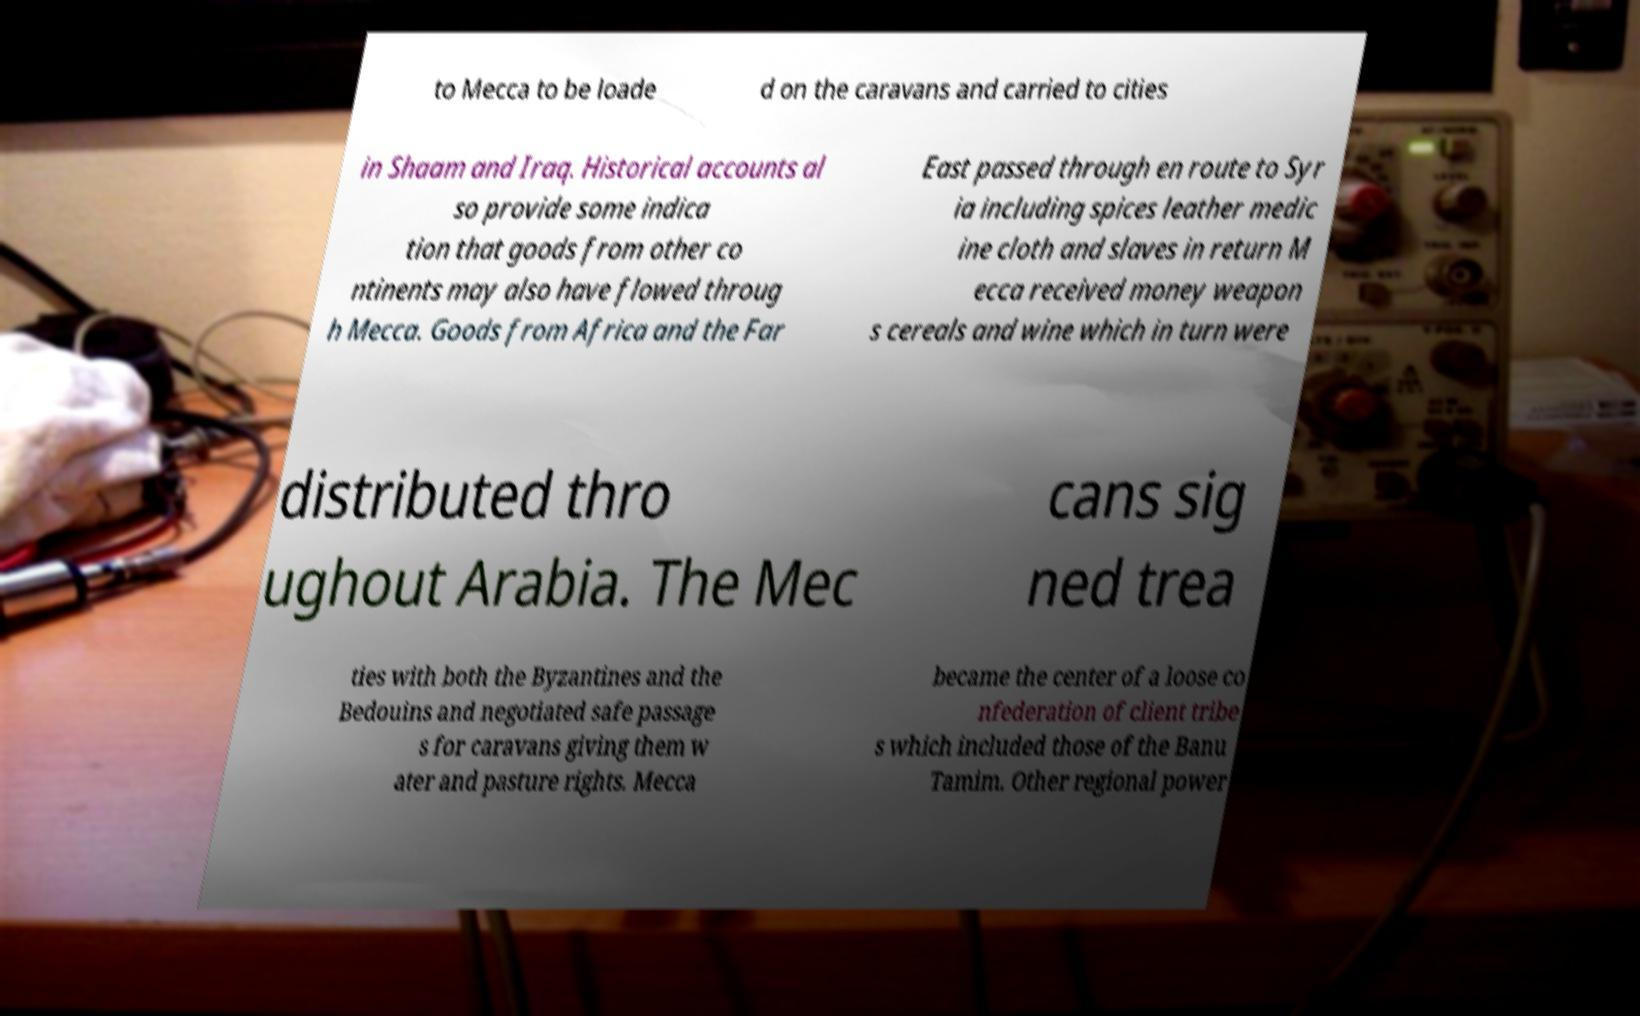Could you assist in decoding the text presented in this image and type it out clearly? to Mecca to be loade d on the caravans and carried to cities in Shaam and Iraq. Historical accounts al so provide some indica tion that goods from other co ntinents may also have flowed throug h Mecca. Goods from Africa and the Far East passed through en route to Syr ia including spices leather medic ine cloth and slaves in return M ecca received money weapon s cereals and wine which in turn were distributed thro ughout Arabia. The Mec cans sig ned trea ties with both the Byzantines and the Bedouins and negotiated safe passage s for caravans giving them w ater and pasture rights. Mecca became the center of a loose co nfederation of client tribe s which included those of the Banu Tamim. Other regional power 